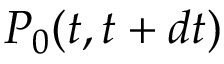<formula> <loc_0><loc_0><loc_500><loc_500>P _ { 0 } ( t , t + d t )</formula> 